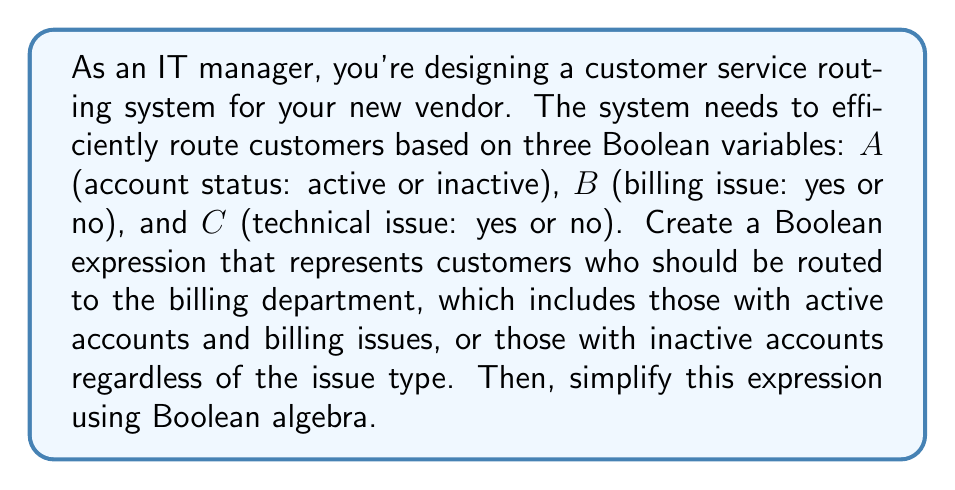Could you help me with this problem? Let's approach this step-by-step:

1) First, we need to translate the routing conditions into a Boolean expression:
   - Customers with active accounts ($A$) AND billing issues ($B$): $A \cdot B$
   - OR customers with inactive accounts ($\overline{A}$): $\overline{A}$

2) Combining these conditions, our initial Boolean expression is:
   $$(A \cdot B) + \overline{A}$$

3) To simplify this expression, we can use the distributive law and complement law:
   $$(A \cdot B) + \overline{A}$$
   $$= (A \cdot B) + (\overline{A} \cdot 1)$$
   $$= (A \cdot B) + (\overline{A} \cdot (B + \overline{B}))$$ (introducing $B + \overline{B} = 1$)

4) Applying the distributive law:
   $$= (A \cdot B) + (\overline{A} \cdot B) + (\overline{A} \cdot \overline{B})$$

5) Factoring out $B$:
   $$= (A + \overline{A}) \cdot B + (\overline{A} \cdot \overline{B})$$

6) Simplifying $(A + \overline{A}) = 1$:
   $$= B + (\overline{A} \cdot \overline{B})$$

This simplified expression represents the most efficient Boolean algebra form for routing customers to the billing department.
Answer: $B + (\overline{A} \cdot \overline{B})$ 